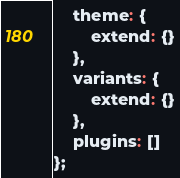Convert code to text. <code><loc_0><loc_0><loc_500><loc_500><_JavaScript_>	theme: {
		extend: {}
	},
	variants: {
		extend: {}
	},
	plugins: []
};
</code> 